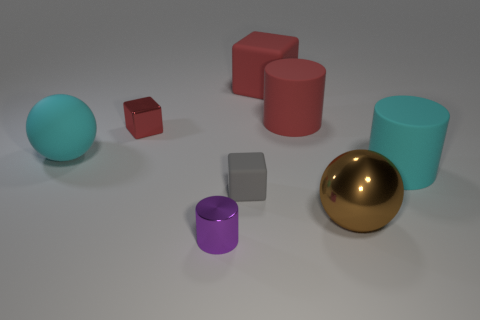There is a shiny sphere that is in front of the cyan rubber object right of the purple cylinder; what is its color?
Offer a terse response. Brown. There is a cylinder that is on the left side of the big brown metal sphere and to the right of the gray object; how big is it?
Your answer should be compact. Large. What number of other things are the same shape as the small gray object?
Offer a terse response. 2. Is the shape of the small red object the same as the cyan matte object that is on the right side of the gray object?
Keep it short and to the point. No. How many cyan cylinders are left of the rubber sphere?
Provide a succinct answer. 0. Are there any other things that are made of the same material as the large brown object?
Keep it short and to the point. Yes. There is a cyan rubber object that is to the right of the large rubber cube; does it have the same shape as the small purple metal thing?
Offer a very short reply. Yes. There is a small block that is to the right of the red metallic object; what is its color?
Offer a terse response. Gray. What shape is the tiny red object that is made of the same material as the purple object?
Make the answer very short. Cube. Are there any other things that are the same color as the tiny cylinder?
Provide a succinct answer. No. 